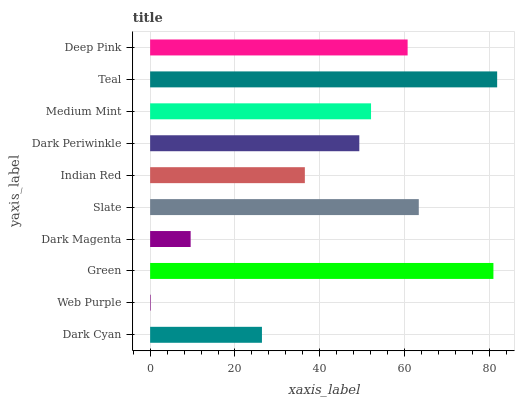Is Web Purple the minimum?
Answer yes or no. Yes. Is Teal the maximum?
Answer yes or no. Yes. Is Green the minimum?
Answer yes or no. No. Is Green the maximum?
Answer yes or no. No. Is Green greater than Web Purple?
Answer yes or no. Yes. Is Web Purple less than Green?
Answer yes or no. Yes. Is Web Purple greater than Green?
Answer yes or no. No. Is Green less than Web Purple?
Answer yes or no. No. Is Medium Mint the high median?
Answer yes or no. Yes. Is Dark Periwinkle the low median?
Answer yes or no. Yes. Is Deep Pink the high median?
Answer yes or no. No. Is Deep Pink the low median?
Answer yes or no. No. 